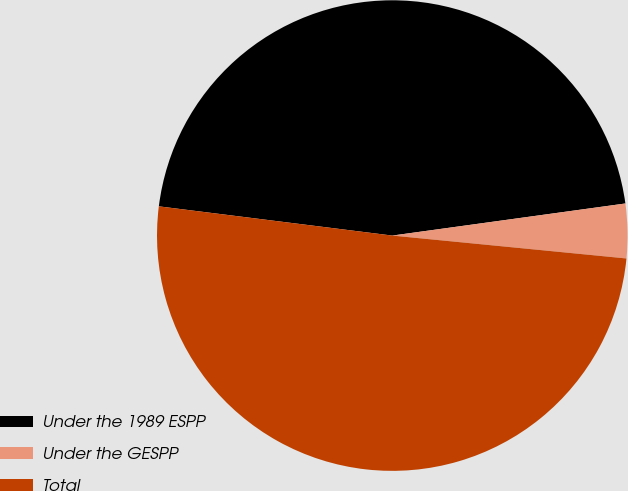Convert chart. <chart><loc_0><loc_0><loc_500><loc_500><pie_chart><fcel>Under the 1989 ESPP<fcel>Under the GESPP<fcel>Total<nl><fcel>45.84%<fcel>3.73%<fcel>50.43%<nl></chart> 